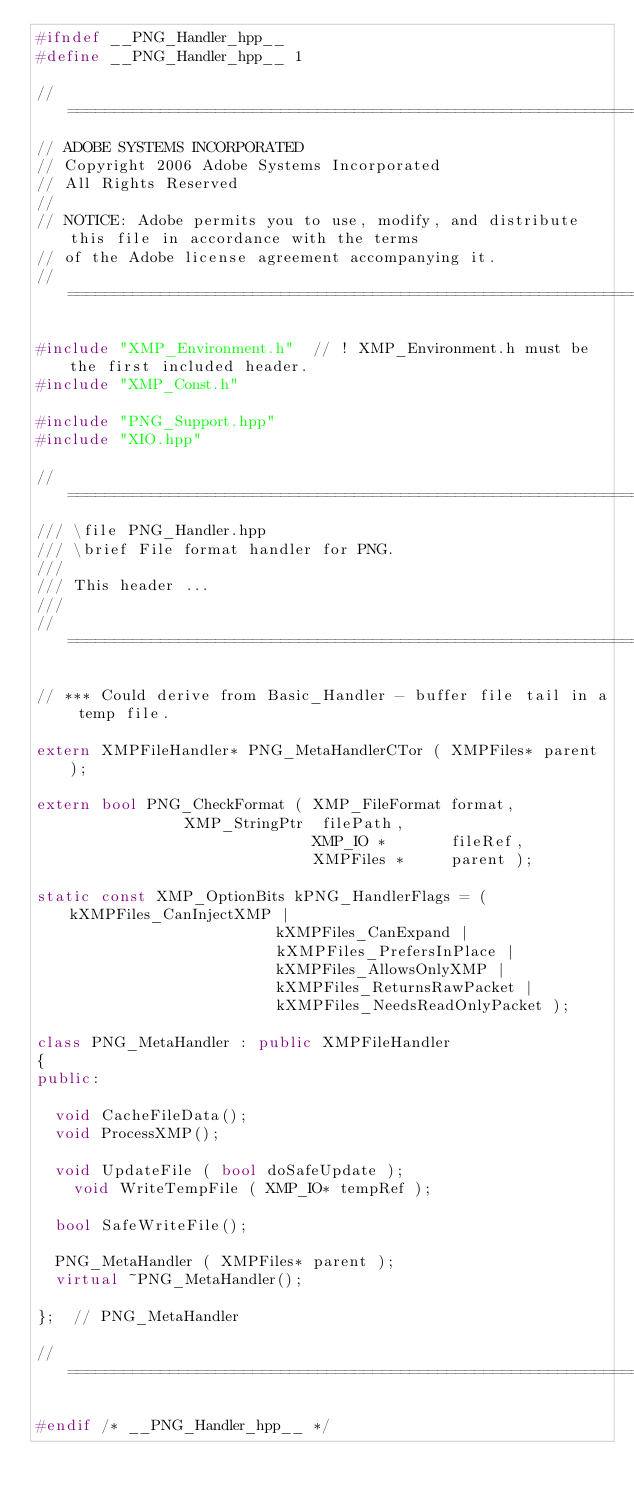Convert code to text. <code><loc_0><loc_0><loc_500><loc_500><_C++_>#ifndef __PNG_Handler_hpp__
#define __PNG_Handler_hpp__	1

// =================================================================================================
// ADOBE SYSTEMS INCORPORATED
// Copyright 2006 Adobe Systems Incorporated
// All Rights Reserved
//
// NOTICE: Adobe permits you to use, modify, and distribute this file in accordance with the terms
// of the Adobe license agreement accompanying it.
// =================================================================================================

#include "XMP_Environment.h"	// ! XMP_Environment.h must be the first included header.
#include "XMP_Const.h"

#include "PNG_Support.hpp"
#include "XIO.hpp"

// =================================================================================================
/// \file PNG_Handler.hpp
/// \brief File format handler for PNG.
///
/// This header ...
///
// =================================================================================================

// *** Could derive from Basic_Handler - buffer file tail in a temp file.

extern XMPFileHandler* PNG_MetaHandlerCTor ( XMPFiles* parent );

extern bool PNG_CheckFormat ( XMP_FileFormat format,
							  XMP_StringPtr  filePath,
                              XMP_IO *       fileRef,
                              XMPFiles *     parent );

static const XMP_OptionBits kPNG_HandlerFlags = ( kXMPFiles_CanInjectXMP |
												  kXMPFiles_CanExpand |
												  kXMPFiles_PrefersInPlace |
												  kXMPFiles_AllowsOnlyXMP |
												  kXMPFiles_ReturnsRawPacket |
												  kXMPFiles_NeedsReadOnlyPacket );

class PNG_MetaHandler : public XMPFileHandler
{
public:

	void CacheFileData();
	void ProcessXMP();

	void UpdateFile ( bool doSafeUpdate );
    void WriteTempFile ( XMP_IO* tempRef );

	bool SafeWriteFile();

	PNG_MetaHandler ( XMPFiles* parent );
	virtual ~PNG_MetaHandler();

};	// PNG_MetaHandler

// =================================================================================================

#endif /* __PNG_Handler_hpp__ */
</code> 